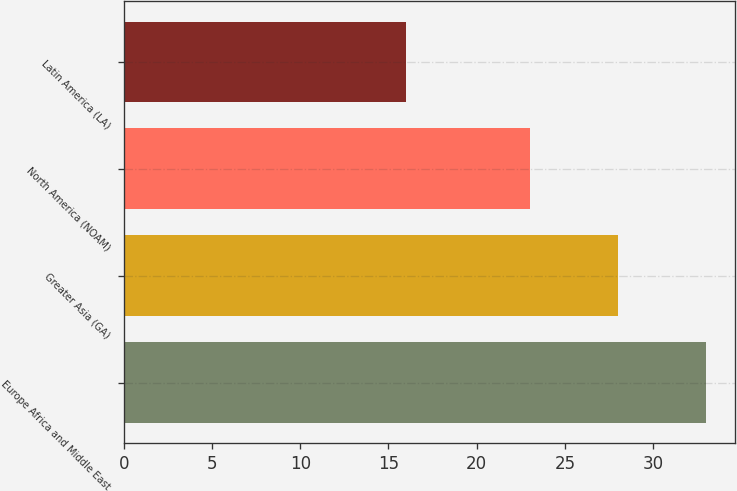Convert chart to OTSL. <chart><loc_0><loc_0><loc_500><loc_500><bar_chart><fcel>Europe Africa and Middle East<fcel>Greater Asia (GA)<fcel>North America (NOAM)<fcel>Latin America (LA)<nl><fcel>33<fcel>28<fcel>23<fcel>16<nl></chart> 